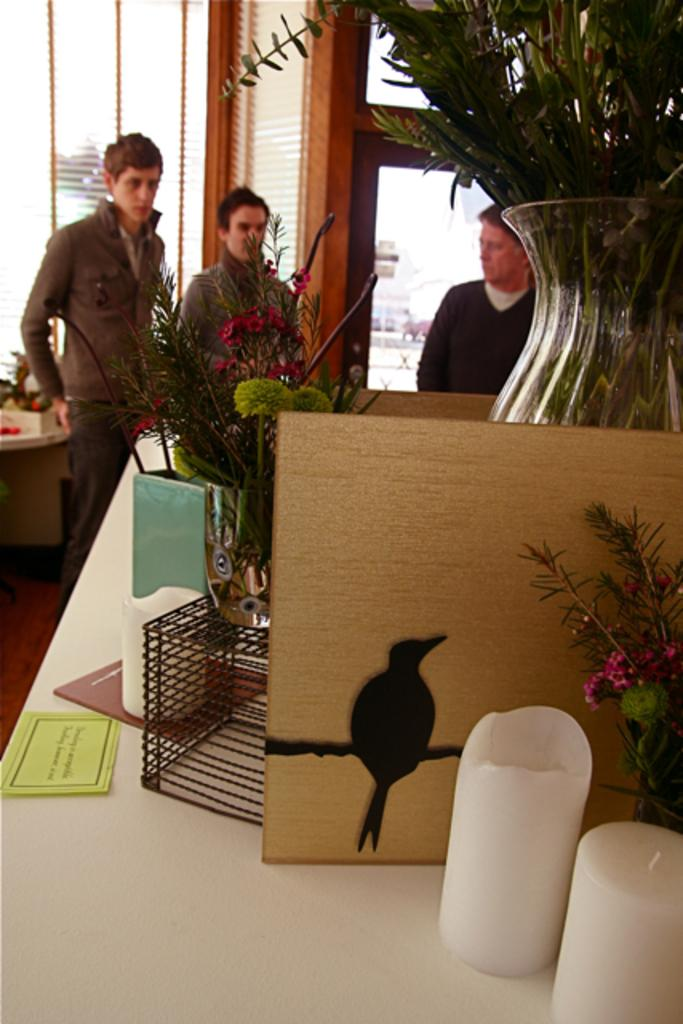What objects can be seen in the image related to lighting? There are candles in the image. What object in the image is used for holding flowers? There is a flower vase in the image. What can be found on the table in the image? There are unspecified things on the table. What is visible in the background of the image? There are people standing in the background of the image. How many kitties are performing division on the table in the image? There are no kitties or any indication of division present in the image. 